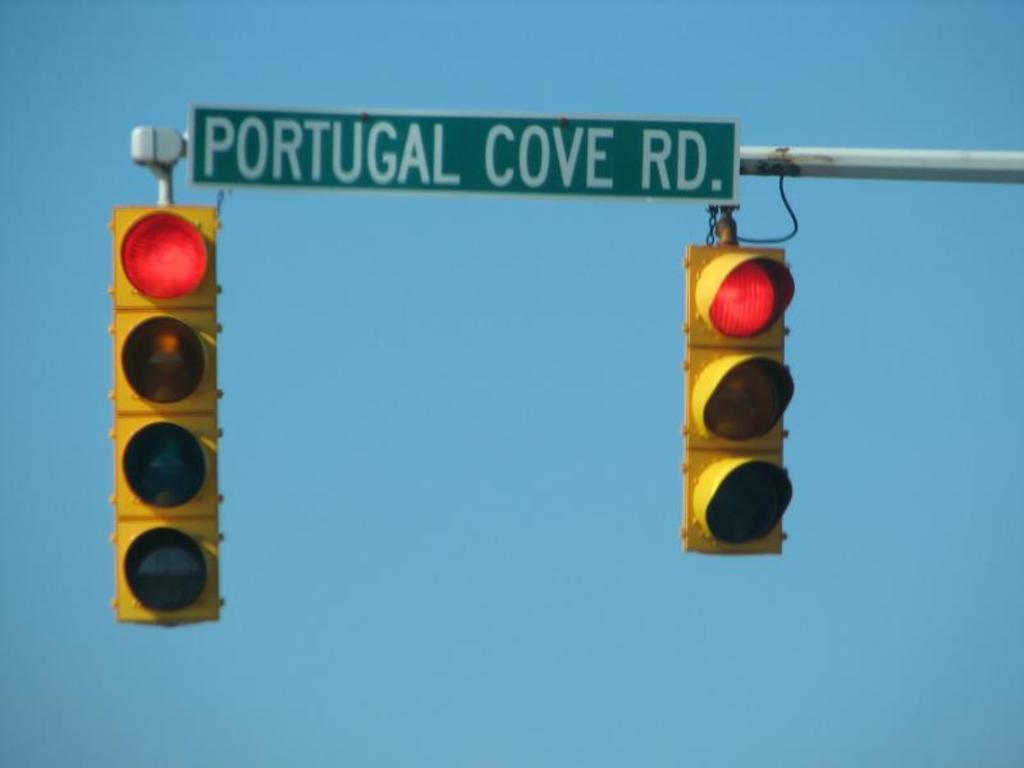What road is the traffic light at?
Ensure brevity in your answer.  Portugal cove rd. 